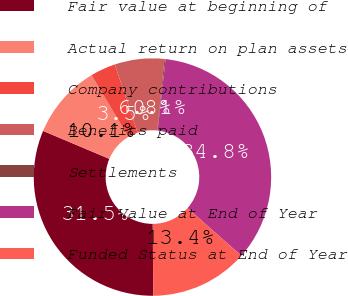<chart> <loc_0><loc_0><loc_500><loc_500><pie_chart><fcel>Fair value at beginning of<fcel>Actual return on plan assets<fcel>Company contributions<fcel>Benefits paid<fcel>Settlements<fcel>Fair Value at End of Year<fcel>Funded Status at End of Year<nl><fcel>31.46%<fcel>10.06%<fcel>3.45%<fcel>6.75%<fcel>0.14%<fcel>34.77%<fcel>13.36%<nl></chart> 